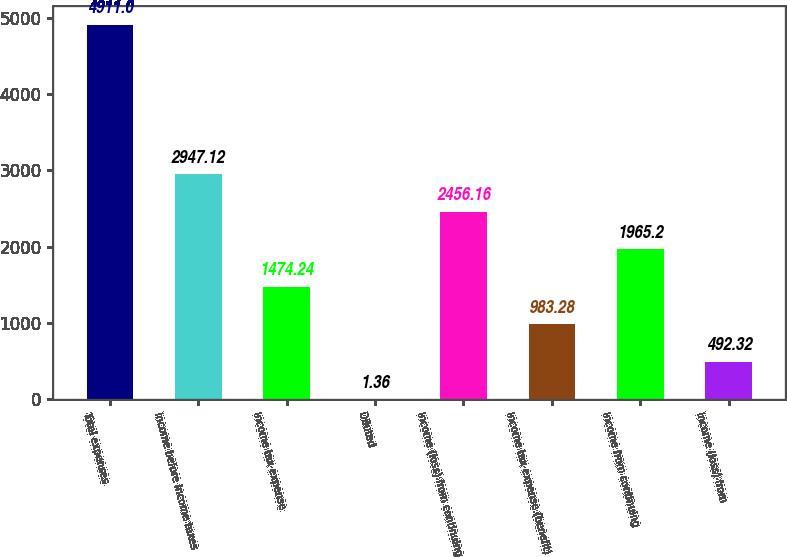Convert chart to OTSL. <chart><loc_0><loc_0><loc_500><loc_500><bar_chart><fcel>Total expenses<fcel>Income before income taxes<fcel>Income tax expense<fcel>Diluted<fcel>Income (loss) from continuing<fcel>Income tax expense (benefit)<fcel>Income from continuing<fcel>Income (loss) from<nl><fcel>4911<fcel>2947.12<fcel>1474.24<fcel>1.36<fcel>2456.16<fcel>983.28<fcel>1965.2<fcel>492.32<nl></chart> 